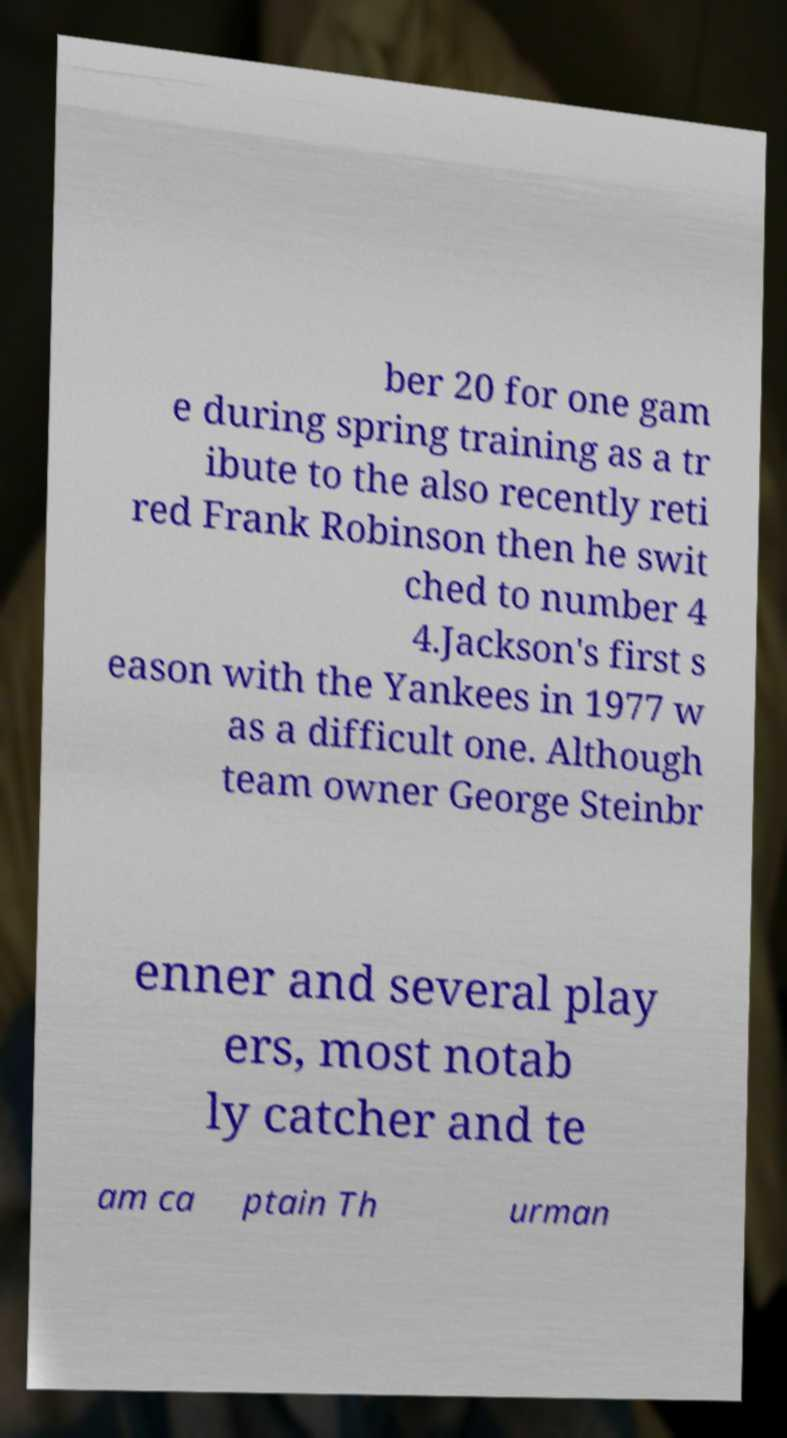Please read and relay the text visible in this image. What does it say? ber 20 for one gam e during spring training as a tr ibute to the also recently reti red Frank Robinson then he swit ched to number 4 4.Jackson's first s eason with the Yankees in 1977 w as a difficult one. Although team owner George Steinbr enner and several play ers, most notab ly catcher and te am ca ptain Th urman 